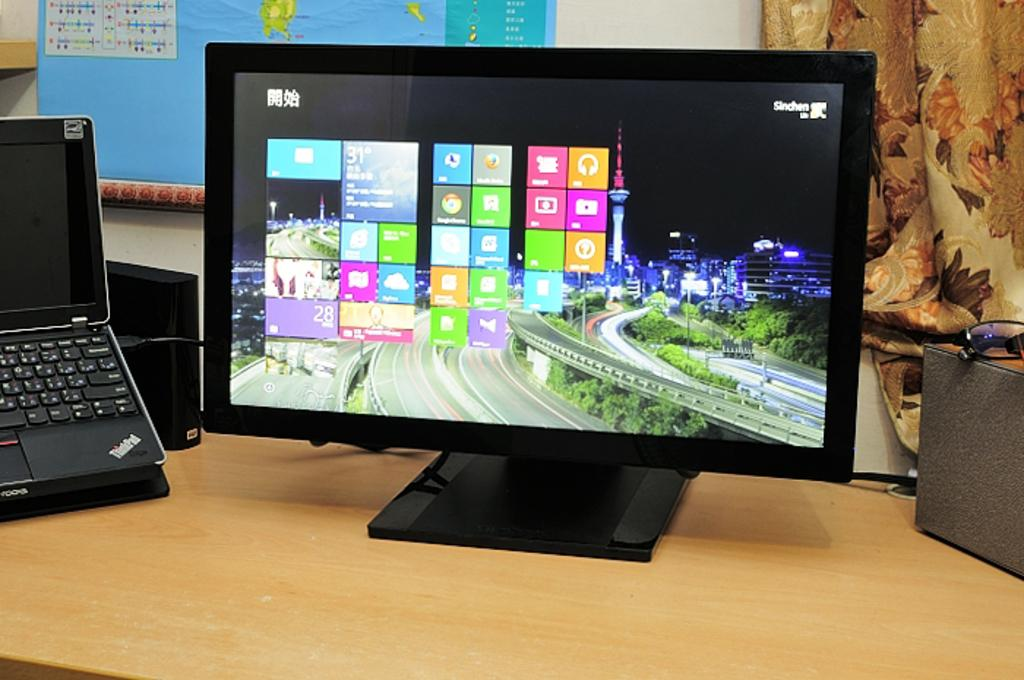Provide a one-sentence caption for the provided image. A large computer monitor is next to an open ThinkPad laptop. 